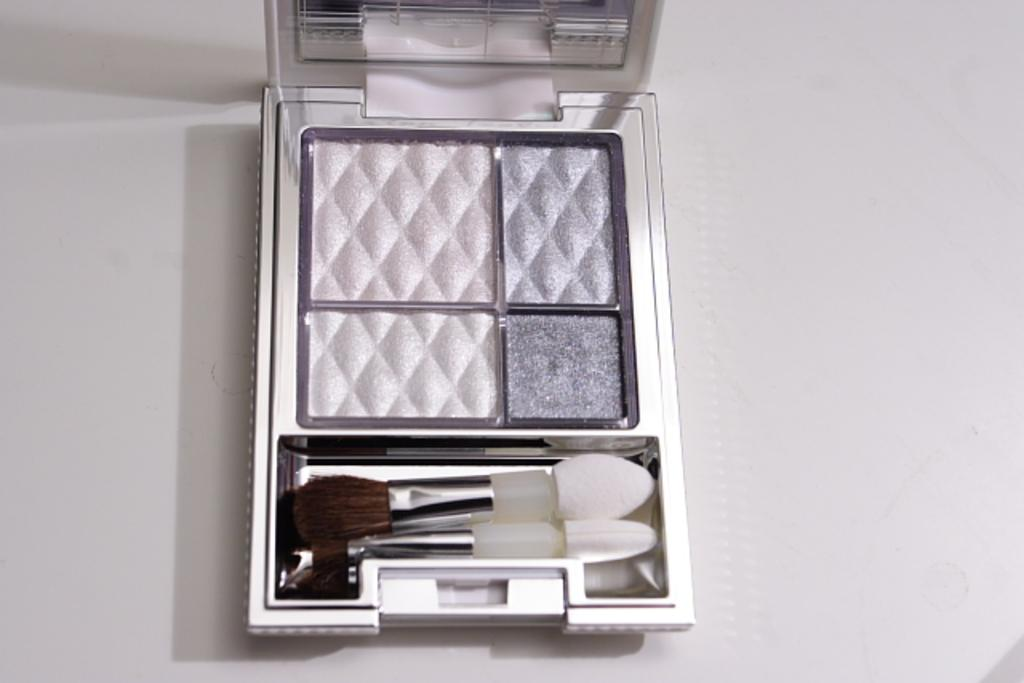What is the color of the surface in the image? The surface in the image is white. What is placed on the white surface? There is a makeup kit on the surface. What items are included in the makeup kit? The makeup kit contains two small brushes. Can you see a baby playing a drum in the image? There is no baby or drum present in the image; it features a white surface with a makeup kit containing two small brushes. 